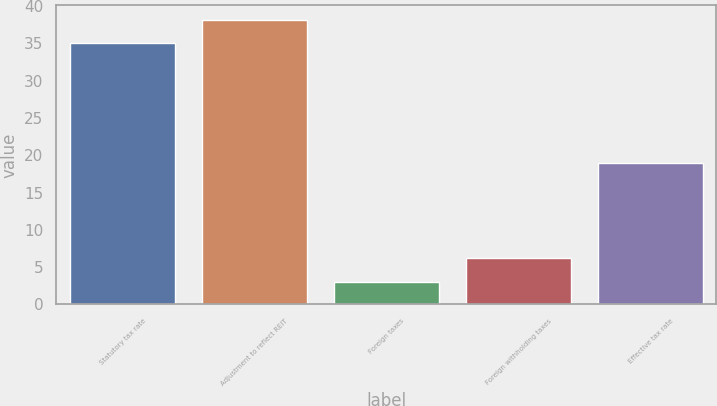<chart> <loc_0><loc_0><loc_500><loc_500><bar_chart><fcel>Statutory tax rate<fcel>Adjustment to reflect REIT<fcel>Foreign taxes<fcel>Foreign withholding taxes<fcel>Effective tax rate<nl><fcel>35<fcel>38.2<fcel>3<fcel>6.2<fcel>19<nl></chart> 